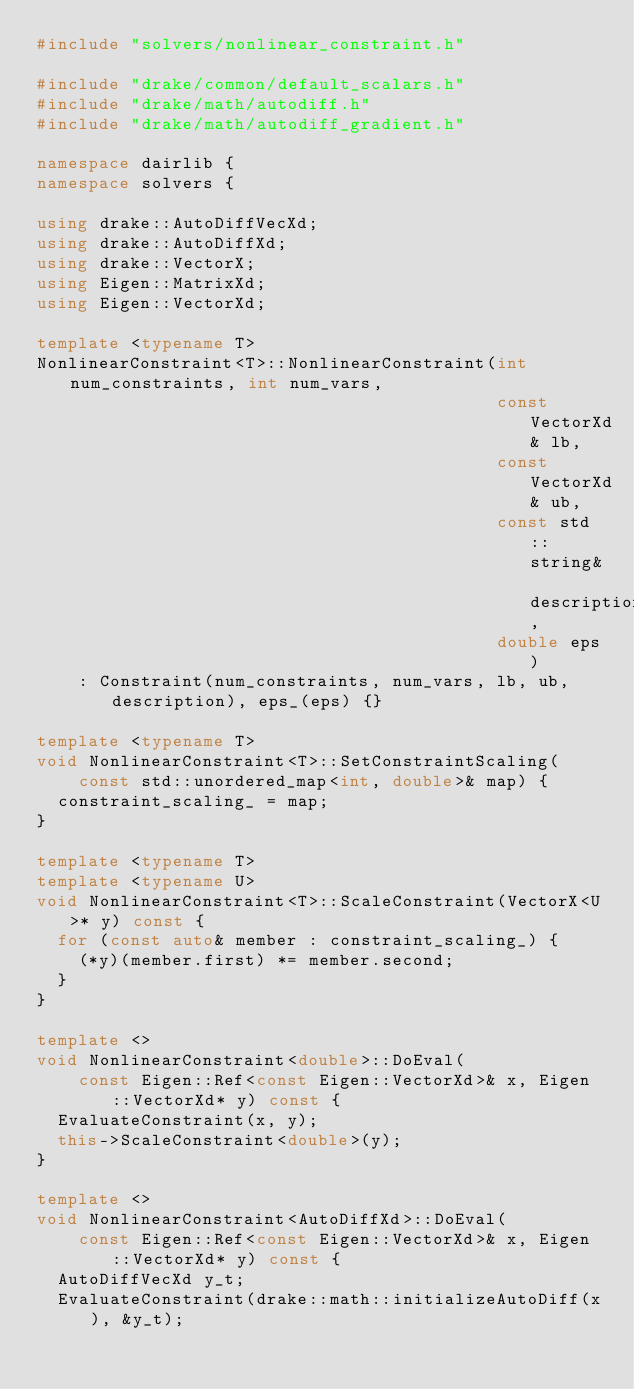Convert code to text. <code><loc_0><loc_0><loc_500><loc_500><_C++_>#include "solvers/nonlinear_constraint.h"

#include "drake/common/default_scalars.h"
#include "drake/math/autodiff.h"
#include "drake/math/autodiff_gradient.h"

namespace dairlib {
namespace solvers {

using drake::AutoDiffVecXd;
using drake::AutoDiffXd;
using drake::VectorX;
using Eigen::MatrixXd;
using Eigen::VectorXd;

template <typename T>
NonlinearConstraint<T>::NonlinearConstraint(int num_constraints, int num_vars,
                                            const VectorXd& lb,
                                            const VectorXd& ub,
                                            const std::string& description,
                                            double eps)
    : Constraint(num_constraints, num_vars, lb, ub, description), eps_(eps) {}

template <typename T>
void NonlinearConstraint<T>::SetConstraintScaling(
    const std::unordered_map<int, double>& map) {
  constraint_scaling_ = map;
}

template <typename T>
template <typename U>
void NonlinearConstraint<T>::ScaleConstraint(VectorX<U>* y) const {
  for (const auto& member : constraint_scaling_) {
    (*y)(member.first) *= member.second;
  }
}

template <>
void NonlinearConstraint<double>::DoEval(
    const Eigen::Ref<const Eigen::VectorXd>& x, Eigen::VectorXd* y) const {
  EvaluateConstraint(x, y);
  this->ScaleConstraint<double>(y);
}

template <>
void NonlinearConstraint<AutoDiffXd>::DoEval(
    const Eigen::Ref<const Eigen::VectorXd>& x, Eigen::VectorXd* y) const {
  AutoDiffVecXd y_t;
  EvaluateConstraint(drake::math::initializeAutoDiff(x), &y_t);</code> 